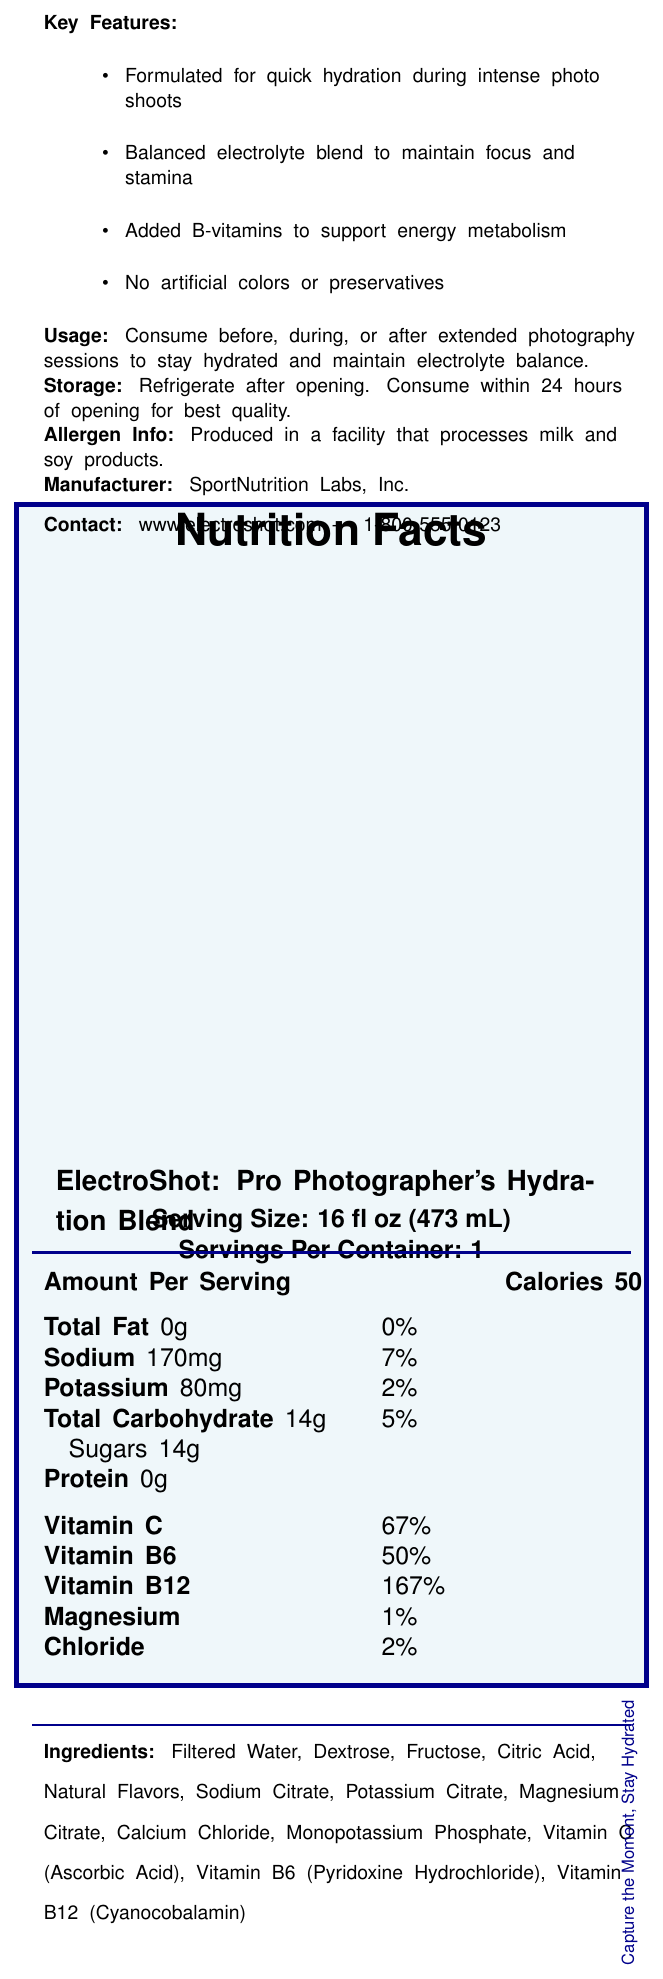what is the serving size of ElectroShot? The serving size is listed as 16 fl oz (473 mL) in the document.
Answer: 16 fl oz (473 mL) how many calories are in one serving of ElectroShot? The document states that there are 50 calories per serving.
Answer: 50 what is the amount of sodium per serving? The amount of sodium per serving is displayed as 170mg.
Answer: 170mg how many grams of sugars does one serving of ElectroShot contain? The document specifies that there are 14g of sugars in one serving.
Answer: 14g what percentage of the daily value of Vitamin C is provided by one serving? The percentage daily value of Vitamin C provided by one serving is 67%.
Answer: 67% which of the following ingredients is not found in ElectroShot? A. Filtered Water B. Sodium Benzoate C. Citric Acid D. Fructose Sodium Benzoate is not listed in the ingredients of ElectroShot.
Answer: B which vitamin has the highest percentage daily value in a single serving? A. Vitamin C B. Vitamin B6 C. Vitamin B12 D. Chloride Vitamin B12 has the highest percentage daily value at 167%.
Answer: C is ElectroShot suitable for someone who needs to avoid artificial colors? Yes/No The document states that ElectroShot has no artificial colors or preservatives.
Answer: Yes provide a brief summary of the ElectroShot product based on the document. The document highlights ElectroShot's purpose, nutrition information, key ingredients, and features to give an overview of the product.
Answer: ElectroShot is a sports drink designed for photographers, providing hydration and essential electrolytes. It contains 50 calories per serving, with key ingredients like sodium and potassium to maintain electrolyte balance. It also includes significant percentages of various vitamins such as Vitamin C and B12. The drink is free from artificial colors and preservatives, and is best consumed before, during, or after extended photography sessions. what is the purpose of the B-vitamins added in ElectroShot? The document states that B-vitamins are included to support energy metabolism.
Answer: To support energy metabolism can you find the contact number for SportNutrition Labs, Inc. in the document? The contact number for SportNutrition Labs, Inc. is 1-800-555-0123 as mentioned in the document.
Answer: 1-800-555-0123 how much protein content is in one serving of ElectroShot? The document indicates that there is no protein (0g) in one serving of ElectroShot.
Answer: 0g where should ElectroShot be stored after opening? The document advises to refrigerate the product after opening.
Answer: Refrigerate after opening what type of facilities is ElectroShot produced in regarding allergens? The document mentions that ElectroShot is produced in a facility that processes milk and soy products.
Answer: Produced in a facility that processes milk and soy products can you determine how many bottles are in a pack of ElectroShot from the document? The document does not provide information on the number of bottles in a pack of ElectroShot.
Answer: Not enough information 